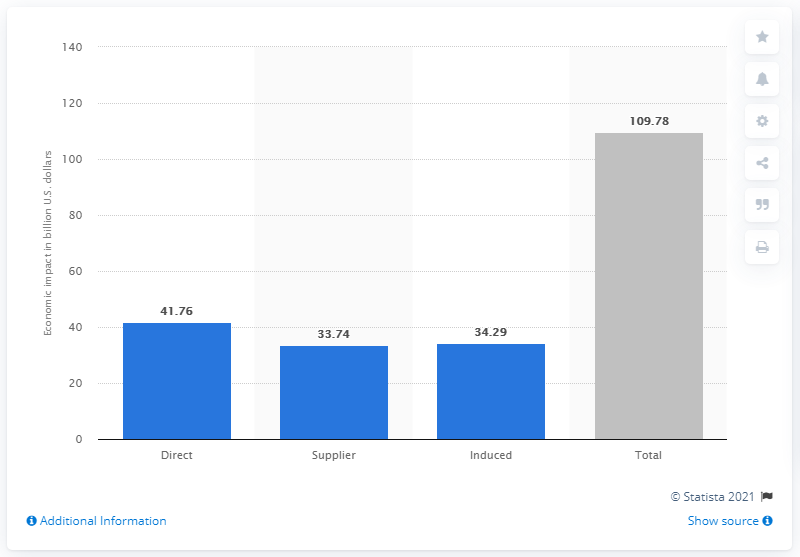Draw attention to some important aspects in this diagram. In the United States, the total economic impact of the scrap recycling industry was $109.78 billion in 2020. In 2019, the direct impact of the scrap recycling industry was estimated to be $41.76 billion. 